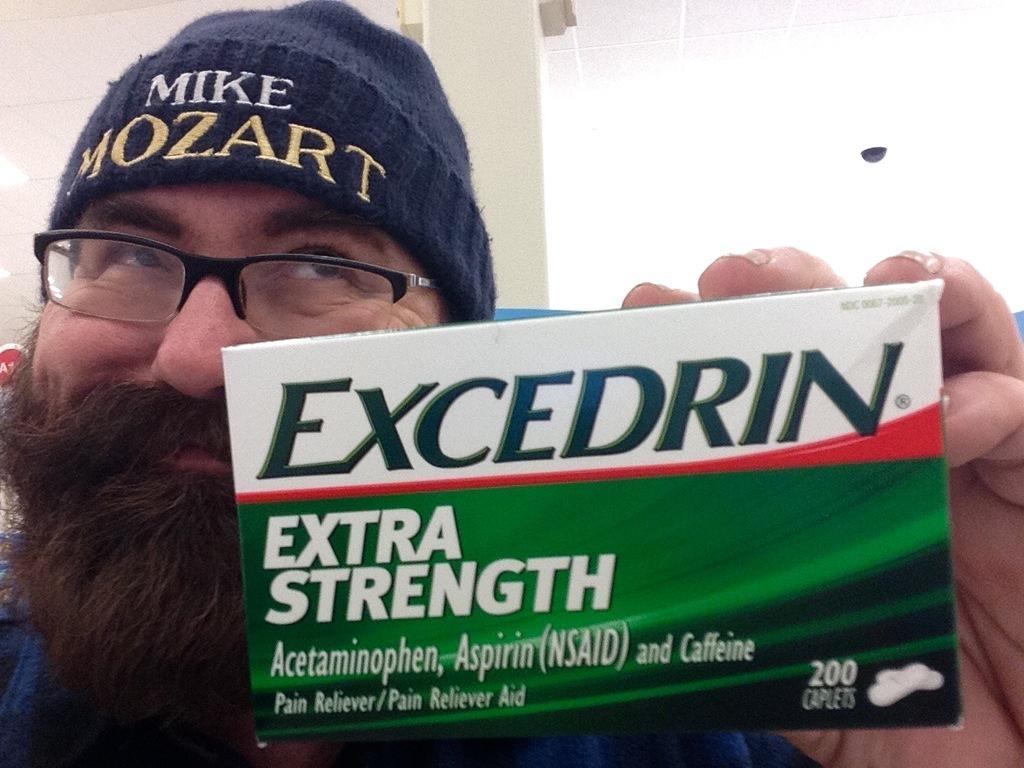Could you give a brief overview of what you see in this image? In this image I can see a person holding something with some text written on it. 